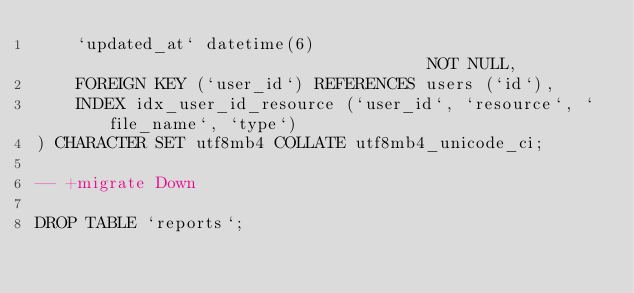<code> <loc_0><loc_0><loc_500><loc_500><_SQL_>    `updated_at` datetime(6)                                 NOT NULL,
    FOREIGN KEY (`user_id`) REFERENCES users (`id`),
    INDEX idx_user_id_resource (`user_id`, `resource`, `file_name`, `type`)
) CHARACTER SET utf8mb4 COLLATE utf8mb4_unicode_ci;

-- +migrate Down

DROP TABLE `reports`;</code> 